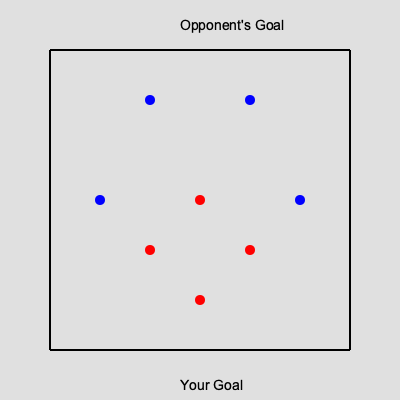In a power play situation, your team (red) has 5 players on the ice while the opponent (blue) has 4. Given the current positions of the opponent's players, what formation should your team adopt to maximize scoring opportunities? Consider the principles of creating passing lanes and maintaining puck possession. To determine the best formation for a power play, we need to analyze the opponent's positions and create a strategy that maximizes our team's scoring opportunities. Let's break it down step-by-step:

1. Opponent's formation: The blue team has adopted a diamond formation, which is common for penalty killing. They have two players high, one on each side, and two players low, forming a diamond shape.

2. Scoring areas: The most dangerous scoring areas are typically in the slot (area directly in front of the goal) and the face-off circles.

3. Passing lanes: We want to create passing options that can quickly move the puck between players and potentially open up shooting lanes.

4. Puck possession: Maintaining control of the puck is crucial in a power play situation.

5. Optimal formation: Given these factors, the best formation for our team would be an "umbrella" power play setup:

   a. One player at the point (top center of the offensive zone)
   b. Two players on the half-boards (one on each side, slightly lower than the point player)
   c. One player in the high slot
   d. One player near the goal line, to the side of the net

This formation allows for:
- Quick puck movement between the point and half-board players
- A player in the high slot for potential one-timers or deflections
- A player near the goal line for low-to-high passes and potential rebounds
- Multiple passing and shooting options that can stretch the opponent's defense

By adopting this formation, we create a numerical advantage on one side of the ice, forcing the opponent to shift their defense and potentially open up scoring opportunities.
Answer: Umbrella formation 